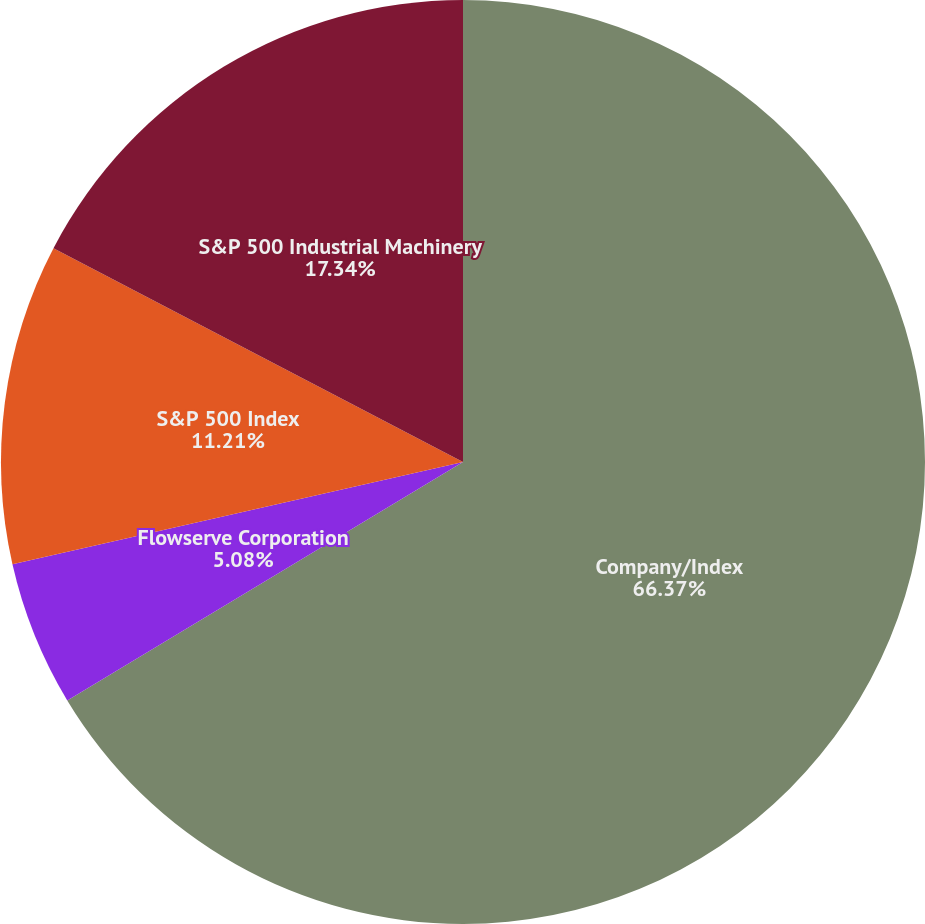<chart> <loc_0><loc_0><loc_500><loc_500><pie_chart><fcel>Company/Index<fcel>Flowserve Corporation<fcel>S&P 500 Index<fcel>S&P 500 Industrial Machinery<nl><fcel>66.37%<fcel>5.08%<fcel>11.21%<fcel>17.34%<nl></chart> 